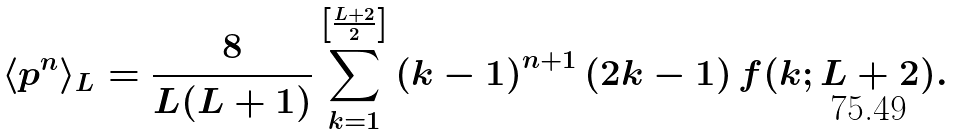Convert formula to latex. <formula><loc_0><loc_0><loc_500><loc_500>\langle p ^ { n } \rangle _ { L } = \frac { 8 } { L ( L + 1 ) } \sum _ { k = 1 } ^ { \left [ \frac { L + 2 } { 2 } \right ] } \left ( k - 1 \right ) ^ { n + 1 } \left ( 2 k - 1 \right ) f ( k ; L + 2 ) .</formula> 